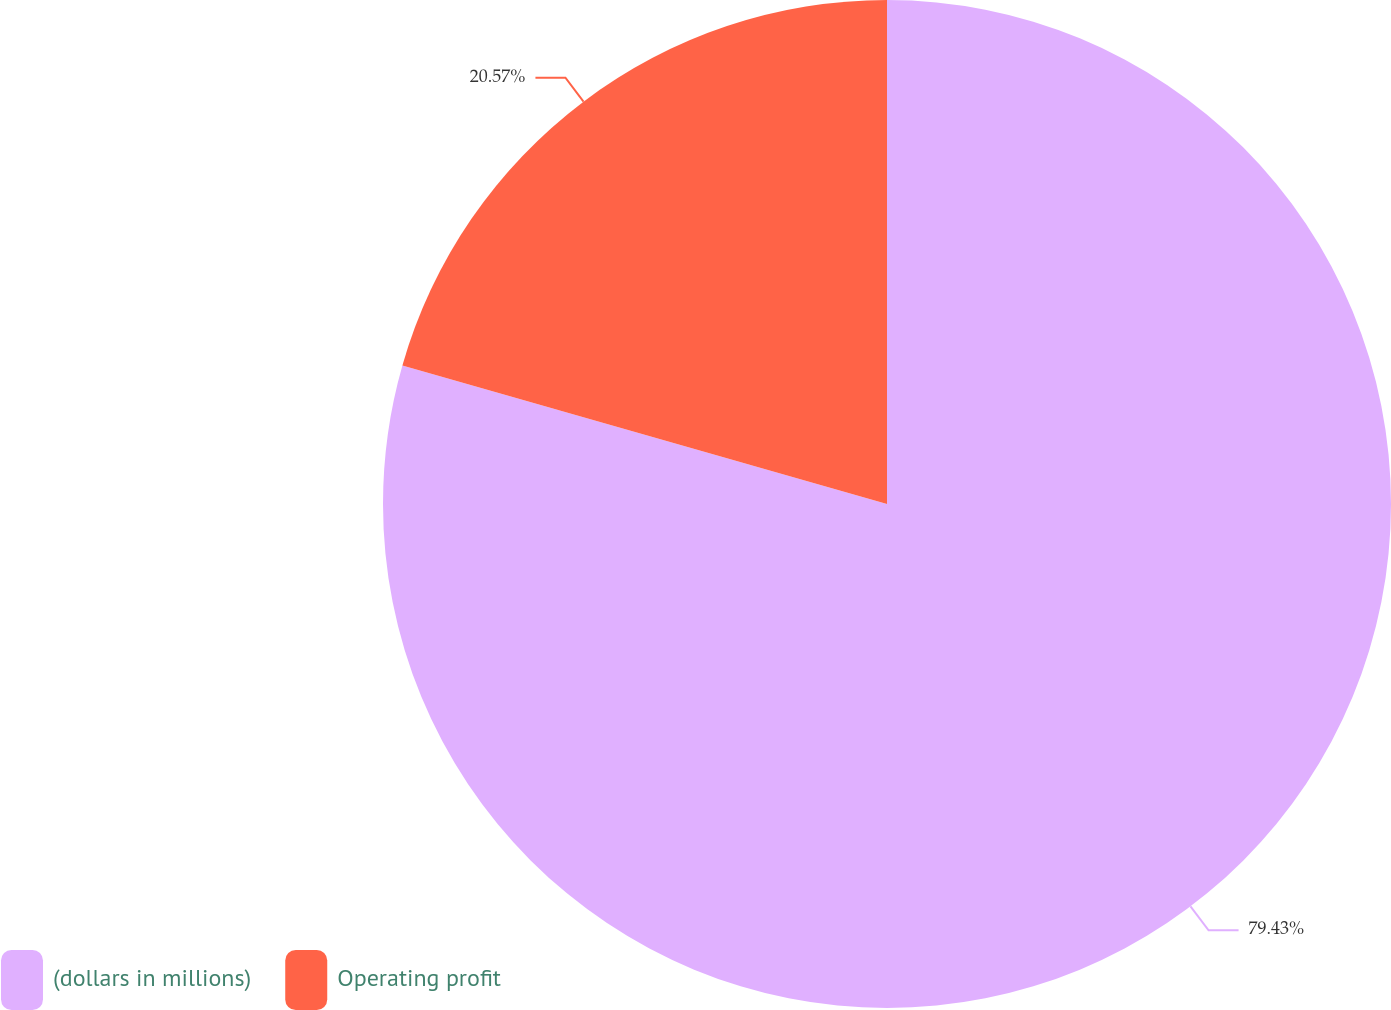<chart> <loc_0><loc_0><loc_500><loc_500><pie_chart><fcel>(dollars in millions)<fcel>Operating profit<nl><fcel>79.43%<fcel>20.57%<nl></chart> 